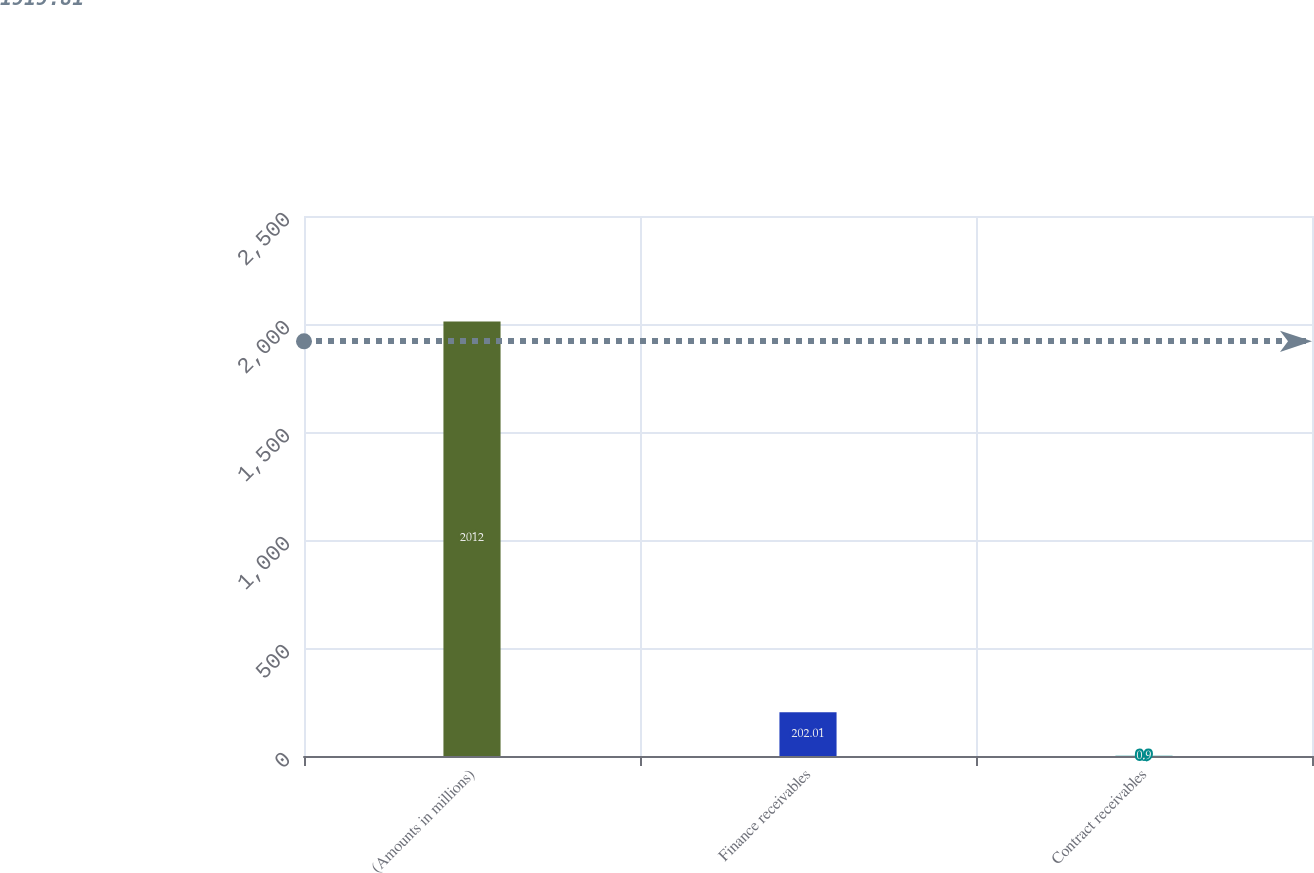<chart> <loc_0><loc_0><loc_500><loc_500><bar_chart><fcel>(Amounts in millions)<fcel>Finance receivables<fcel>Contract receivables<nl><fcel>2012<fcel>202.01<fcel>0.9<nl></chart> 